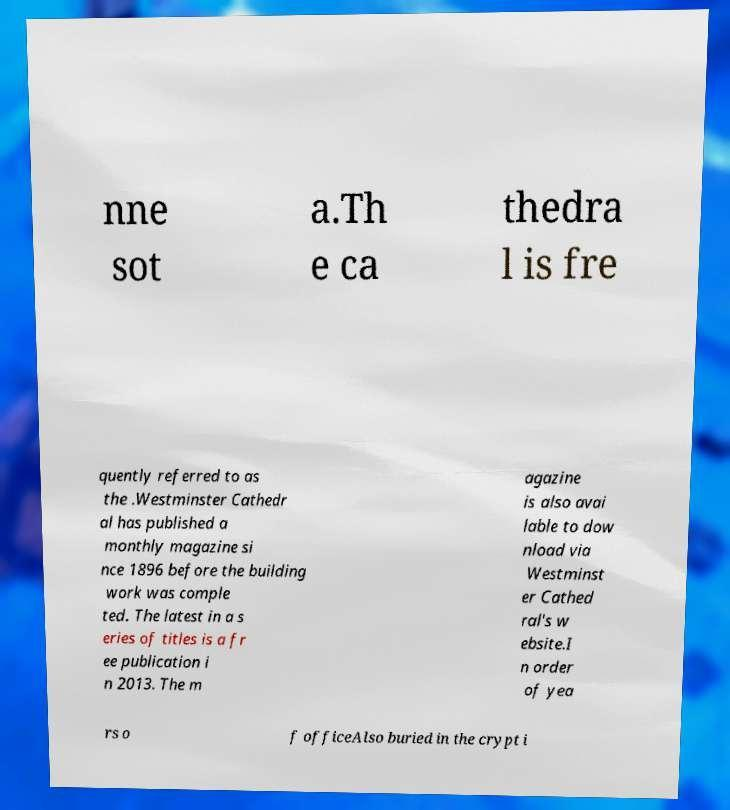Can you accurately transcribe the text from the provided image for me? nne sot a.Th e ca thedra l is fre quently referred to as the .Westminster Cathedr al has published a monthly magazine si nce 1896 before the building work was comple ted. The latest in a s eries of titles is a fr ee publication i n 2013. The m agazine is also avai lable to dow nload via Westminst er Cathed ral's w ebsite.I n order of yea rs o f officeAlso buried in the crypt i 